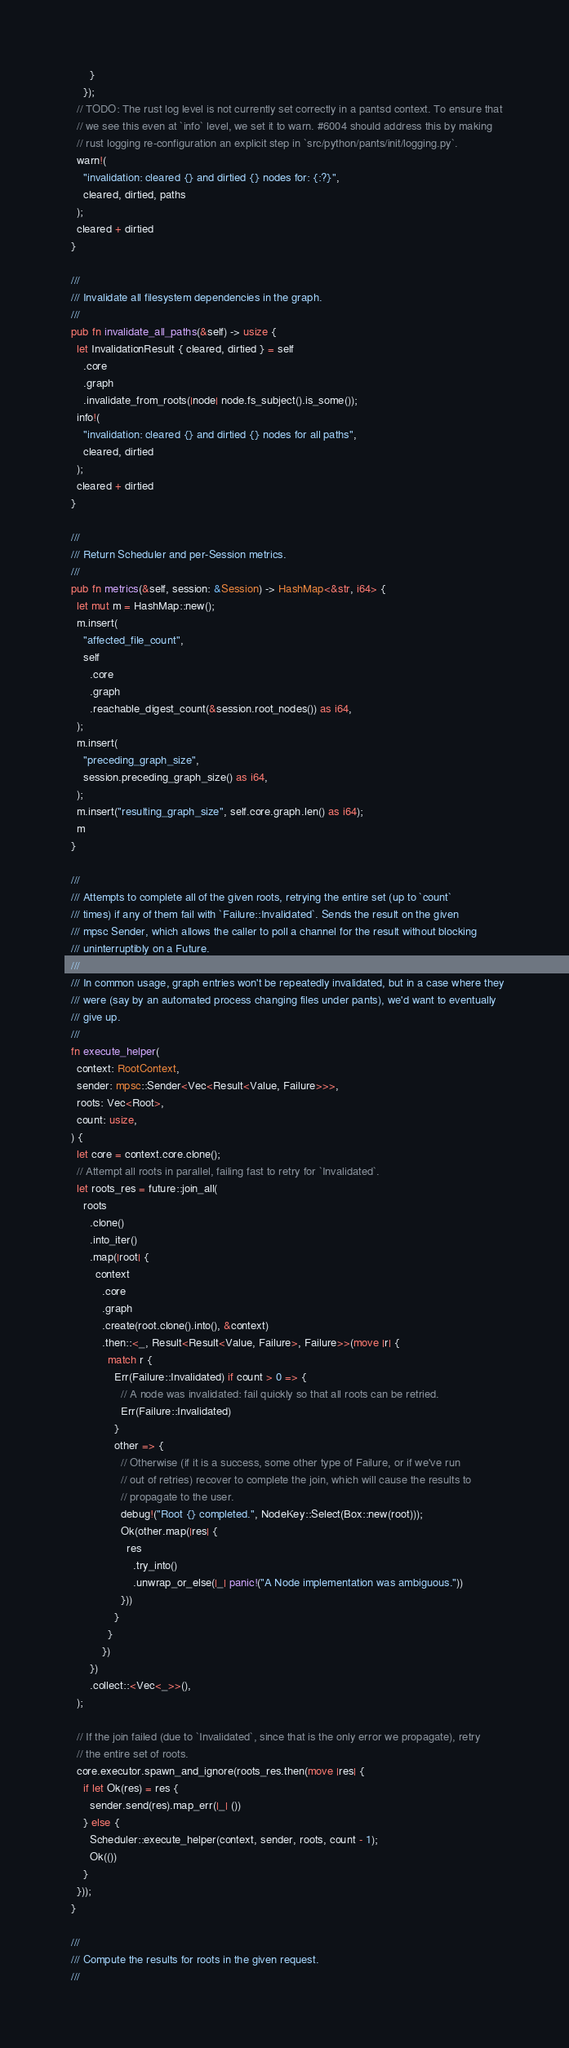<code> <loc_0><loc_0><loc_500><loc_500><_Rust_>        }
      });
    // TODO: The rust log level is not currently set correctly in a pantsd context. To ensure that
    // we see this even at `info` level, we set it to warn. #6004 should address this by making
    // rust logging re-configuration an explicit step in `src/python/pants/init/logging.py`.
    warn!(
      "invalidation: cleared {} and dirtied {} nodes for: {:?}",
      cleared, dirtied, paths
    );
    cleared + dirtied
  }

  ///
  /// Invalidate all filesystem dependencies in the graph.
  ///
  pub fn invalidate_all_paths(&self) -> usize {
    let InvalidationResult { cleared, dirtied } = self
      .core
      .graph
      .invalidate_from_roots(|node| node.fs_subject().is_some());
    info!(
      "invalidation: cleared {} and dirtied {} nodes for all paths",
      cleared, dirtied
    );
    cleared + dirtied
  }

  ///
  /// Return Scheduler and per-Session metrics.
  ///
  pub fn metrics(&self, session: &Session) -> HashMap<&str, i64> {
    let mut m = HashMap::new();
    m.insert(
      "affected_file_count",
      self
        .core
        .graph
        .reachable_digest_count(&session.root_nodes()) as i64,
    );
    m.insert(
      "preceding_graph_size",
      session.preceding_graph_size() as i64,
    );
    m.insert("resulting_graph_size", self.core.graph.len() as i64);
    m
  }

  ///
  /// Attempts to complete all of the given roots, retrying the entire set (up to `count`
  /// times) if any of them fail with `Failure::Invalidated`. Sends the result on the given
  /// mpsc Sender, which allows the caller to poll a channel for the result without blocking
  /// uninterruptibly on a Future.
  ///
  /// In common usage, graph entries won't be repeatedly invalidated, but in a case where they
  /// were (say by an automated process changing files under pants), we'd want to eventually
  /// give up.
  ///
  fn execute_helper(
    context: RootContext,
    sender: mpsc::Sender<Vec<Result<Value, Failure>>>,
    roots: Vec<Root>,
    count: usize,
  ) {
    let core = context.core.clone();
    // Attempt all roots in parallel, failing fast to retry for `Invalidated`.
    let roots_res = future::join_all(
      roots
        .clone()
        .into_iter()
        .map(|root| {
          context
            .core
            .graph
            .create(root.clone().into(), &context)
            .then::<_, Result<Result<Value, Failure>, Failure>>(move |r| {
              match r {
                Err(Failure::Invalidated) if count > 0 => {
                  // A node was invalidated: fail quickly so that all roots can be retried.
                  Err(Failure::Invalidated)
                }
                other => {
                  // Otherwise (if it is a success, some other type of Failure, or if we've run
                  // out of retries) recover to complete the join, which will cause the results to
                  // propagate to the user.
                  debug!("Root {} completed.", NodeKey::Select(Box::new(root)));
                  Ok(other.map(|res| {
                    res
                      .try_into()
                      .unwrap_or_else(|_| panic!("A Node implementation was ambiguous."))
                  }))
                }
              }
            })
        })
        .collect::<Vec<_>>(),
    );

    // If the join failed (due to `Invalidated`, since that is the only error we propagate), retry
    // the entire set of roots.
    core.executor.spawn_and_ignore(roots_res.then(move |res| {
      if let Ok(res) = res {
        sender.send(res).map_err(|_| ())
      } else {
        Scheduler::execute_helper(context, sender, roots, count - 1);
        Ok(())
      }
    }));
  }

  ///
  /// Compute the results for roots in the given request.
  ///</code> 